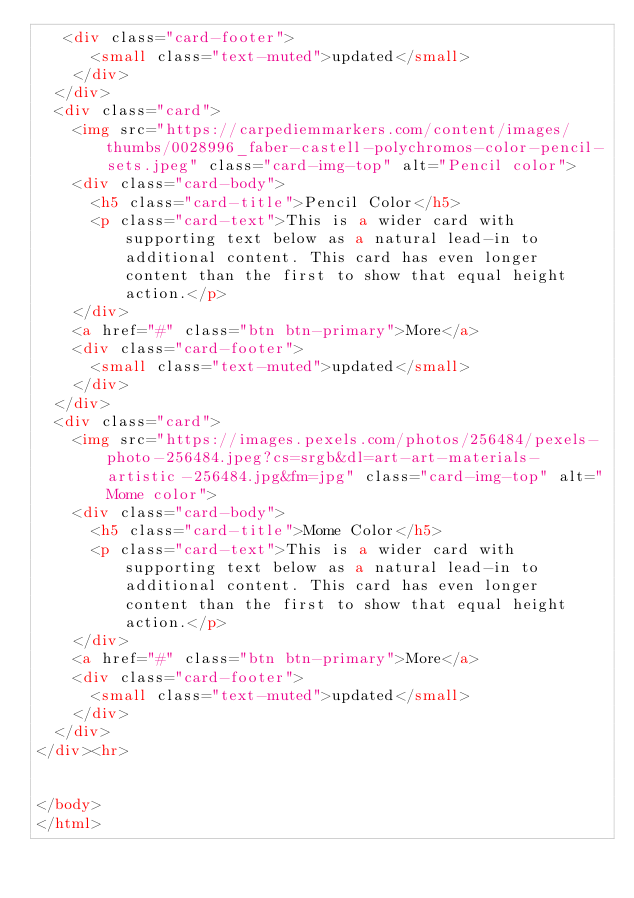<code> <loc_0><loc_0><loc_500><loc_500><_HTML_>   <div class="card-footer">
      <small class="text-muted">updated</small>
    </div>
  </div>
  <div class="card">
    <img src="https://carpediemmarkers.com/content/images/thumbs/0028996_faber-castell-polychromos-color-pencil-sets.jpeg" class="card-img-top" alt="Pencil color">
    <div class="card-body">
      <h5 class="card-title">Pencil Color</h5>
      <p class="card-text">This is a wider card with supporting text below as a natural lead-in to additional content. This card has even longer content than the first to show that equal height action.</p>
    </div>
    <a href="#" class="btn btn-primary">More</a>
    <div class="card-footer">
      <small class="text-muted">updated</small>
    </div>
  </div>
  <div class="card">
    <img src="https://images.pexels.com/photos/256484/pexels-photo-256484.jpeg?cs=srgb&dl=art-art-materials-artistic-256484.jpg&fm=jpg" class="card-img-top" alt="Mome color">
    <div class="card-body">
      <h5 class="card-title">Mome Color</h5>
      <p class="card-text">This is a wider card with supporting text below as a natural lead-in to additional content. This card has even longer content than the first to show that equal height action.</p>
    </div>
    <a href="#" class="btn btn-primary">More</a>
    <div class="card-footer">
      <small class="text-muted">updated</small>
    </div>
  </div>
</div><hr>

  
</body>
</html></code> 